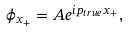Convert formula to latex. <formula><loc_0><loc_0><loc_500><loc_500>\phi _ { x _ { + } } = A e ^ { i p _ { t r u e } x _ { + } } ,</formula> 